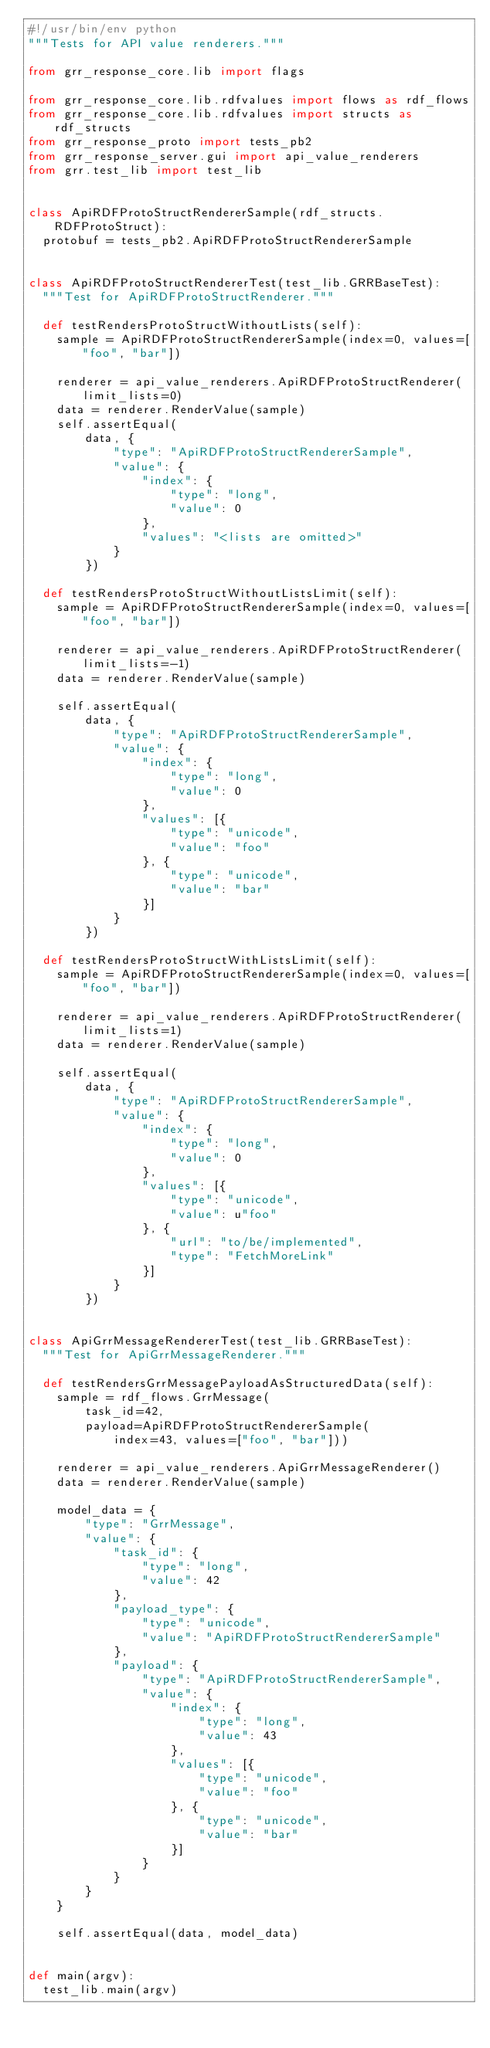<code> <loc_0><loc_0><loc_500><loc_500><_Python_>#!/usr/bin/env python
"""Tests for API value renderers."""

from grr_response_core.lib import flags

from grr_response_core.lib.rdfvalues import flows as rdf_flows
from grr_response_core.lib.rdfvalues import structs as rdf_structs
from grr_response_proto import tests_pb2
from grr_response_server.gui import api_value_renderers
from grr.test_lib import test_lib


class ApiRDFProtoStructRendererSample(rdf_structs.RDFProtoStruct):
  protobuf = tests_pb2.ApiRDFProtoStructRendererSample


class ApiRDFProtoStructRendererTest(test_lib.GRRBaseTest):
  """Test for ApiRDFProtoStructRenderer."""

  def testRendersProtoStructWithoutLists(self):
    sample = ApiRDFProtoStructRendererSample(index=0, values=["foo", "bar"])

    renderer = api_value_renderers.ApiRDFProtoStructRenderer(limit_lists=0)
    data = renderer.RenderValue(sample)
    self.assertEqual(
        data, {
            "type": "ApiRDFProtoStructRendererSample",
            "value": {
                "index": {
                    "type": "long",
                    "value": 0
                },
                "values": "<lists are omitted>"
            }
        })

  def testRendersProtoStructWithoutListsLimit(self):
    sample = ApiRDFProtoStructRendererSample(index=0, values=["foo", "bar"])

    renderer = api_value_renderers.ApiRDFProtoStructRenderer(limit_lists=-1)
    data = renderer.RenderValue(sample)

    self.assertEqual(
        data, {
            "type": "ApiRDFProtoStructRendererSample",
            "value": {
                "index": {
                    "type": "long",
                    "value": 0
                },
                "values": [{
                    "type": "unicode",
                    "value": "foo"
                }, {
                    "type": "unicode",
                    "value": "bar"
                }]
            }
        })

  def testRendersProtoStructWithListsLimit(self):
    sample = ApiRDFProtoStructRendererSample(index=0, values=["foo", "bar"])

    renderer = api_value_renderers.ApiRDFProtoStructRenderer(limit_lists=1)
    data = renderer.RenderValue(sample)

    self.assertEqual(
        data, {
            "type": "ApiRDFProtoStructRendererSample",
            "value": {
                "index": {
                    "type": "long",
                    "value": 0
                },
                "values": [{
                    "type": "unicode",
                    "value": u"foo"
                }, {
                    "url": "to/be/implemented",
                    "type": "FetchMoreLink"
                }]
            }
        })


class ApiGrrMessageRendererTest(test_lib.GRRBaseTest):
  """Test for ApiGrrMessageRenderer."""

  def testRendersGrrMessagePayloadAsStructuredData(self):
    sample = rdf_flows.GrrMessage(
        task_id=42,
        payload=ApiRDFProtoStructRendererSample(
            index=43, values=["foo", "bar"]))

    renderer = api_value_renderers.ApiGrrMessageRenderer()
    data = renderer.RenderValue(sample)

    model_data = {
        "type": "GrrMessage",
        "value": {
            "task_id": {
                "type": "long",
                "value": 42
            },
            "payload_type": {
                "type": "unicode",
                "value": "ApiRDFProtoStructRendererSample"
            },
            "payload": {
                "type": "ApiRDFProtoStructRendererSample",
                "value": {
                    "index": {
                        "type": "long",
                        "value": 43
                    },
                    "values": [{
                        "type": "unicode",
                        "value": "foo"
                    }, {
                        "type": "unicode",
                        "value": "bar"
                    }]
                }
            }
        }
    }

    self.assertEqual(data, model_data)


def main(argv):
  test_lib.main(argv)

</code> 